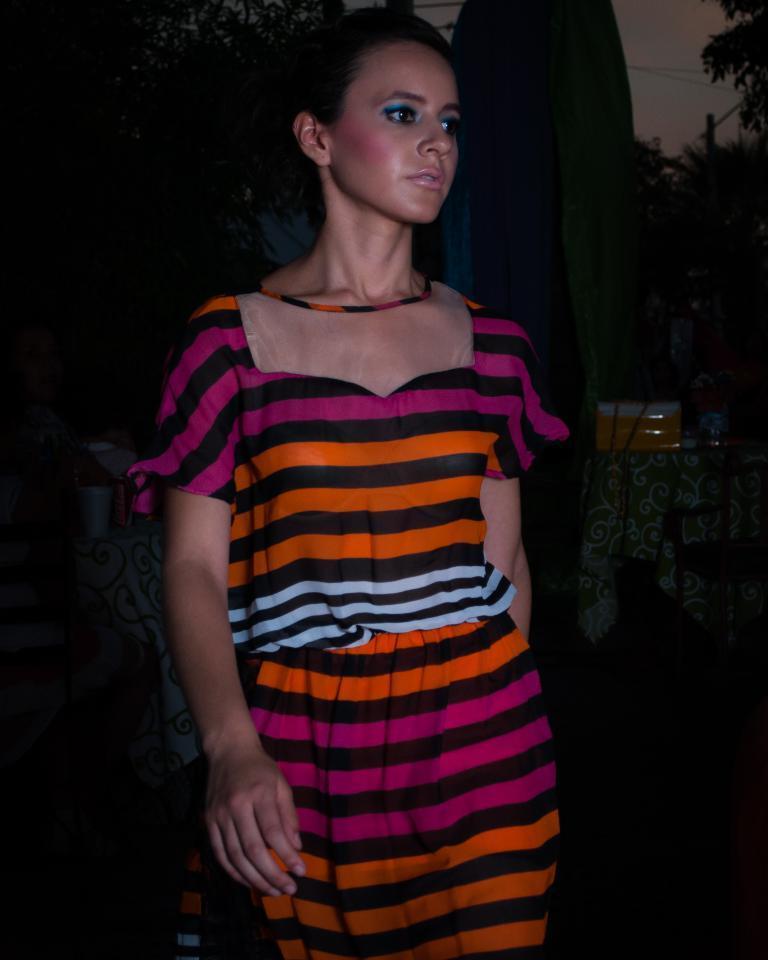In one or two sentences, can you explain what this image depicts? Here we can see a woman. In the background the image is dark but we can see trees,clothes,wires and sky. 